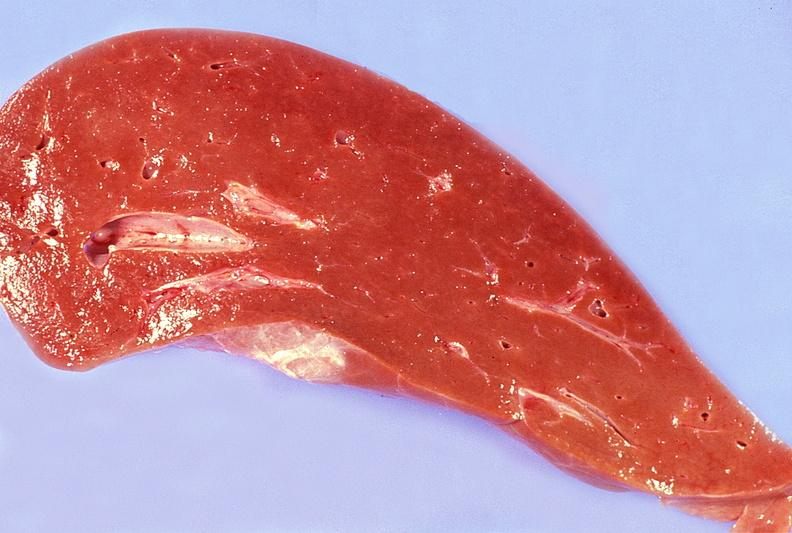s hepatobiliary present?
Answer the question using a single word or phrase. Yes 